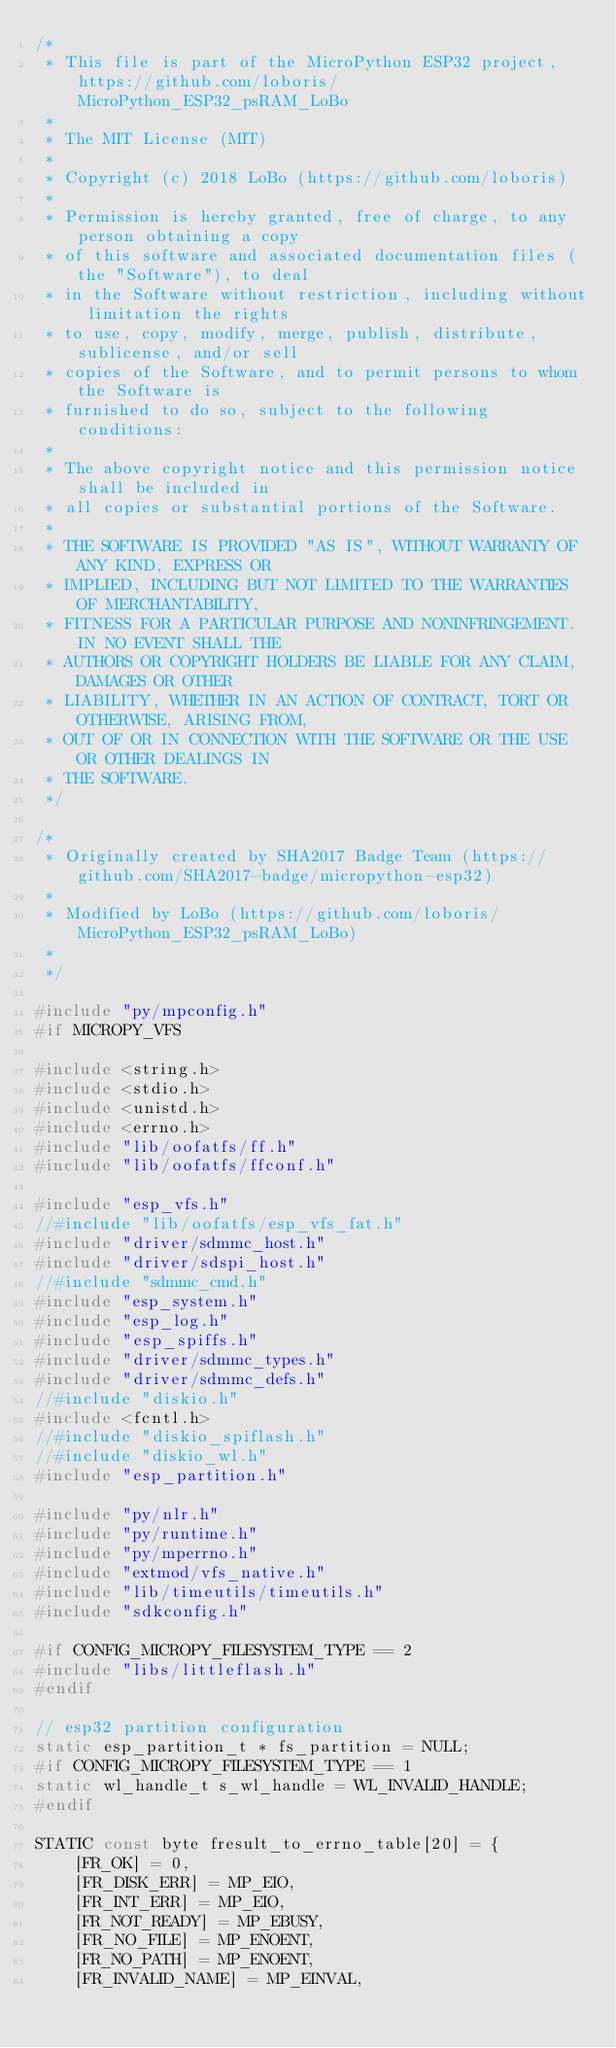<code> <loc_0><loc_0><loc_500><loc_500><_C_>/*
 * This file is part of the MicroPython ESP32 project, https://github.com/loboris/MicroPython_ESP32_psRAM_LoBo
 *
 * The MIT License (MIT)
 *
 * Copyright (c) 2018 LoBo (https://github.com/loboris)
 *
 * Permission is hereby granted, free of charge, to any person obtaining a copy
 * of this software and associated documentation files (the "Software"), to deal
 * in the Software without restriction, including without limitation the rights
 * to use, copy, modify, merge, publish, distribute, sublicense, and/or sell
 * copies of the Software, and to permit persons to whom the Software is
 * furnished to do so, subject to the following conditions:
 *
 * The above copyright notice and this permission notice shall be included in
 * all copies or substantial portions of the Software.
 *
 * THE SOFTWARE IS PROVIDED "AS IS", WITHOUT WARRANTY OF ANY KIND, EXPRESS OR
 * IMPLIED, INCLUDING BUT NOT LIMITED TO THE WARRANTIES OF MERCHANTABILITY,
 * FITNESS FOR A PARTICULAR PURPOSE AND NONINFRINGEMENT. IN NO EVENT SHALL THE
 * AUTHORS OR COPYRIGHT HOLDERS BE LIABLE FOR ANY CLAIM, DAMAGES OR OTHER
 * LIABILITY, WHETHER IN AN ACTION OF CONTRACT, TORT OR OTHERWISE, ARISING FROM,
 * OUT OF OR IN CONNECTION WITH THE SOFTWARE OR THE USE OR OTHER DEALINGS IN
 * THE SOFTWARE.
 */

/*
 * Originally created by SHA2017 Badge Team (https://github.com/SHA2017-badge/micropython-esp32)
 *
 * Modified by LoBo (https://github.com/loboris/MicroPython_ESP32_psRAM_LoBo)
 *
 */

#include "py/mpconfig.h"
#if MICROPY_VFS

#include <string.h>
#include <stdio.h>
#include <unistd.h>
#include <errno.h>
#include "lib/oofatfs/ff.h"
#include "lib/oofatfs/ffconf.h"

#include "esp_vfs.h"
//#include "lib/oofatfs/esp_vfs_fat.h"
#include "driver/sdmmc_host.h"
#include "driver/sdspi_host.h"
//#include "sdmmc_cmd.h"
#include "esp_system.h"
#include "esp_log.h"
#include "esp_spiffs.h"
#include "driver/sdmmc_types.h"
#include "driver/sdmmc_defs.h"
//#include "diskio.h"
#include <fcntl.h>
//#include "diskio_spiflash.h"
//#include "diskio_wl.h"
#include "esp_partition.h"

#include "py/nlr.h"
#include "py/runtime.h"
#include "py/mperrno.h"
#include "extmod/vfs_native.h"
#include "lib/timeutils/timeutils.h"
#include "sdkconfig.h"

#if CONFIG_MICROPY_FILESYSTEM_TYPE == 2
#include "libs/littleflash.h"
#endif

// esp32 partition configuration
static esp_partition_t * fs_partition = NULL;
#if CONFIG_MICROPY_FILESYSTEM_TYPE == 1
static wl_handle_t s_wl_handle = WL_INVALID_HANDLE;
#endif

STATIC const byte fresult_to_errno_table[20] = {
    [FR_OK] = 0,
    [FR_DISK_ERR] = MP_EIO,
    [FR_INT_ERR] = MP_EIO,
    [FR_NOT_READY] = MP_EBUSY,
    [FR_NO_FILE] = MP_ENOENT,
    [FR_NO_PATH] = MP_ENOENT,
    [FR_INVALID_NAME] = MP_EINVAL,</code> 